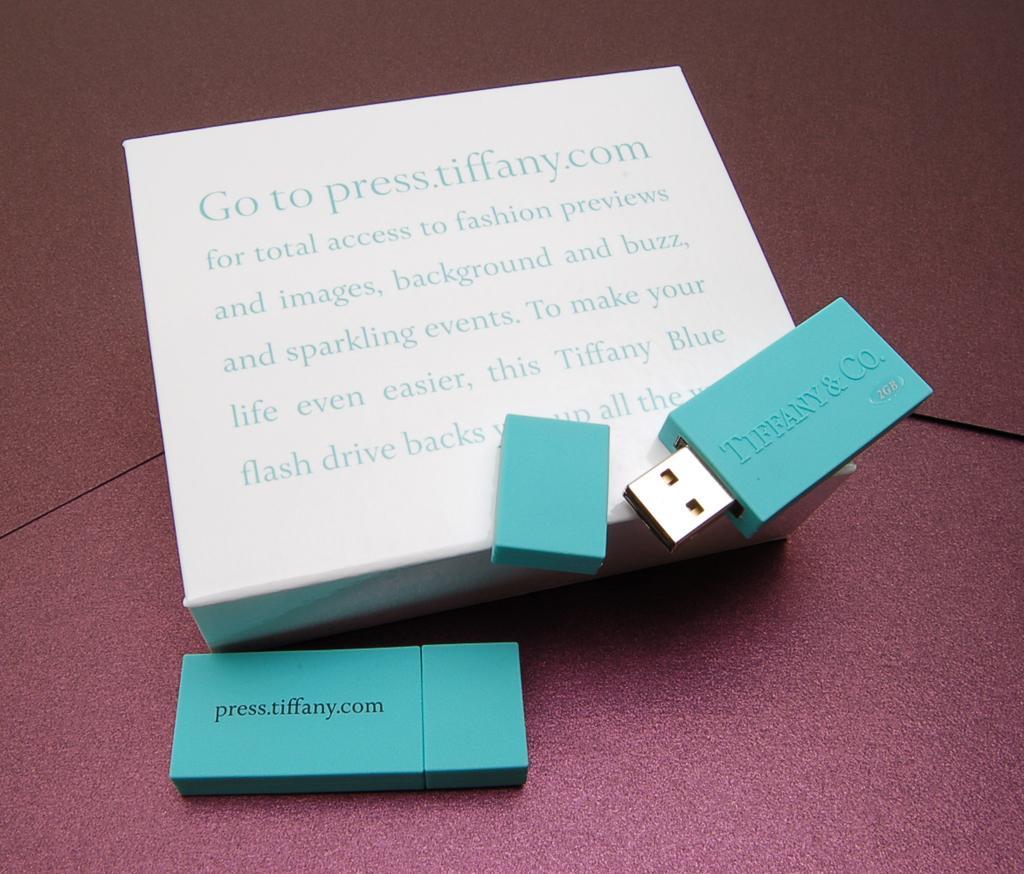Could you give a brief overview of what you see in this image? In this picture, we see the box in white color. We see some text written on it. We see two USB flash drives in blue color. At the bottom, it is purple in color. In the background, it is purple in color. 